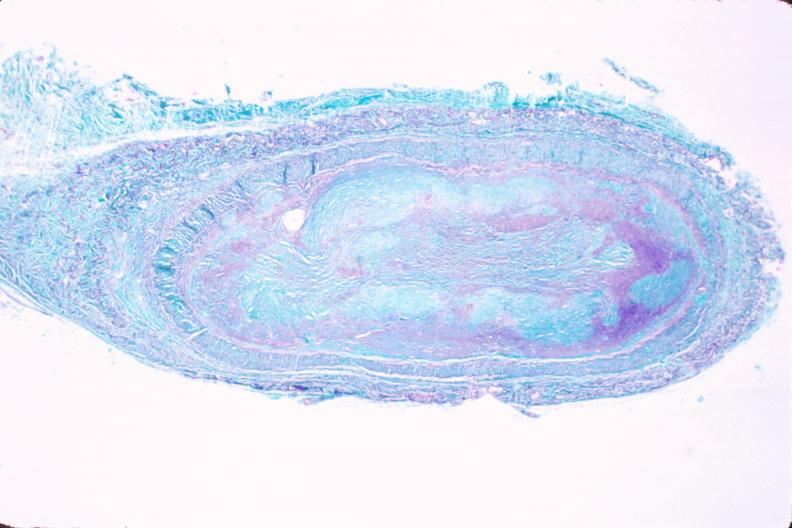what does this image show?
Answer the question using a single word or phrase. Saphenous vein graft sclerosis 